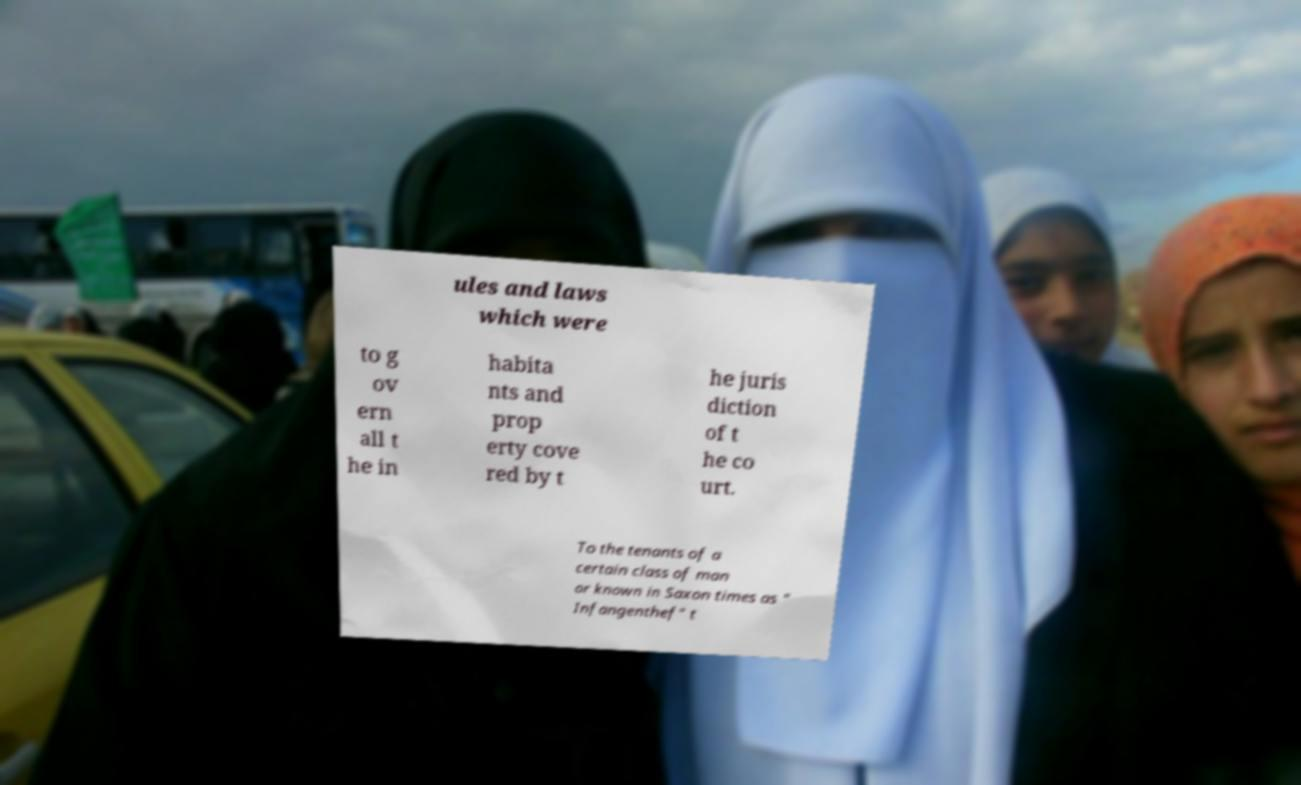Could you extract and type out the text from this image? ules and laws which were to g ov ern all t he in habita nts and prop erty cove red by t he juris diction of t he co urt. To the tenants of a certain class of man or known in Saxon times as " Infangenthef" t 